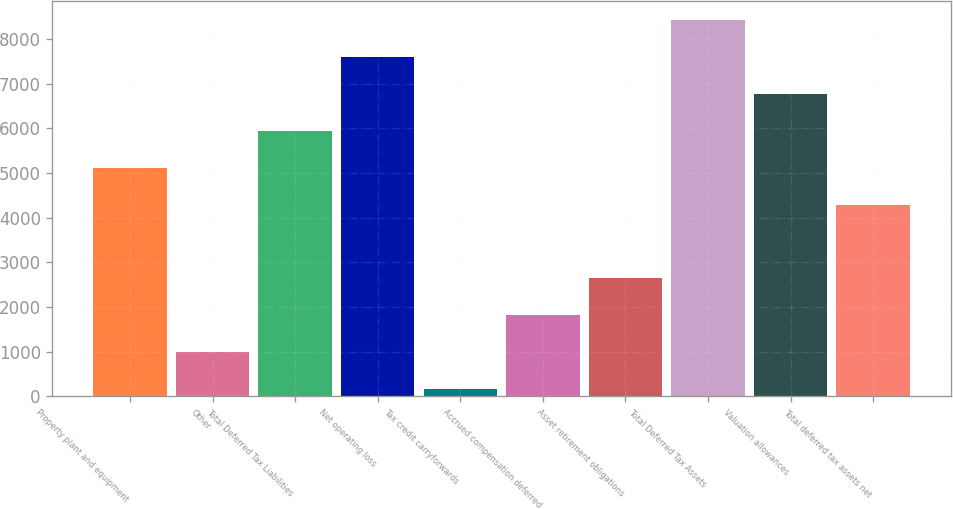<chart> <loc_0><loc_0><loc_500><loc_500><bar_chart><fcel>Property plant and equipment<fcel>Other<fcel>Total Deferred Tax Liabilities<fcel>Net operating loss<fcel>Tax credit carryforwards<fcel>Accrued compensation deferred<fcel>Asset retirement obligations<fcel>Total Deferred Tax Assets<fcel>Valuation allowances<fcel>Total deferred tax assets net<nl><fcel>5123.6<fcel>990.6<fcel>5950.2<fcel>7603.4<fcel>164<fcel>1817.2<fcel>2643.8<fcel>8430<fcel>6776.8<fcel>4297<nl></chart> 